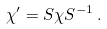Convert formula to latex. <formula><loc_0><loc_0><loc_500><loc_500>\chi ^ { \prime } = S \chi S ^ { - 1 } \, .</formula> 